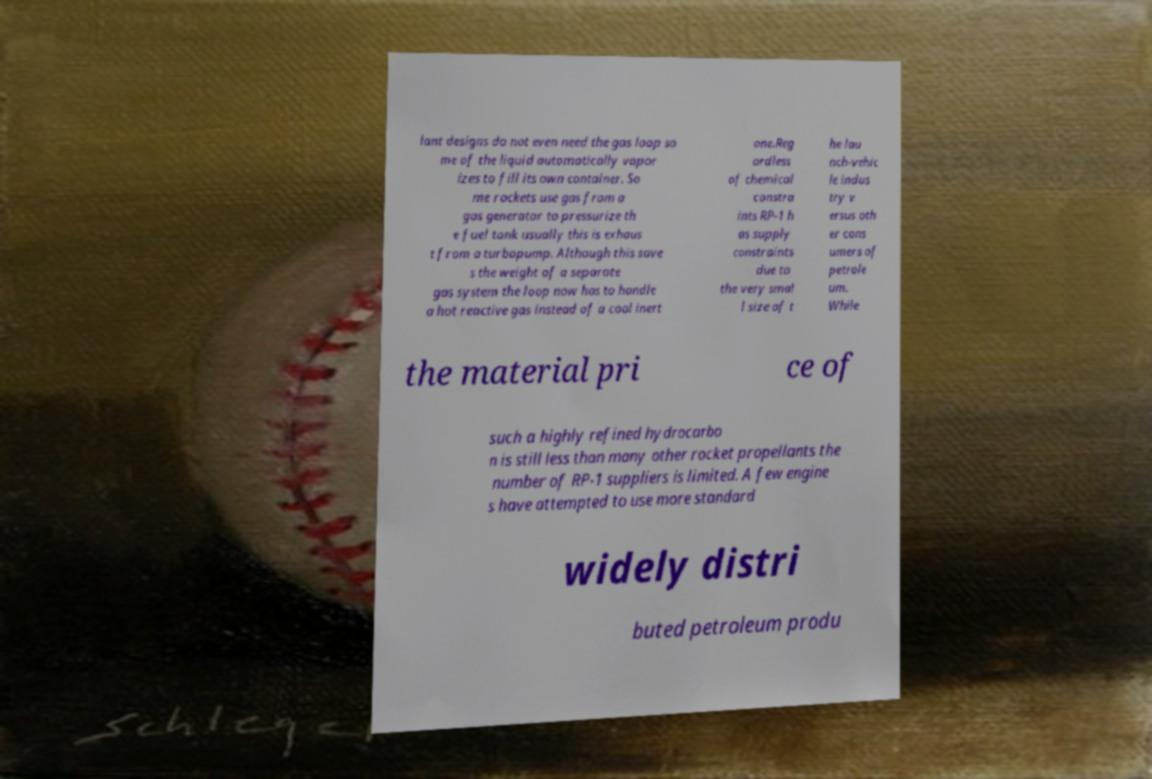There's text embedded in this image that I need extracted. Can you transcribe it verbatim? lant designs do not even need the gas loop so me of the liquid automatically vapor izes to fill its own container. So me rockets use gas from a gas generator to pressurize th e fuel tank usually this is exhaus t from a turbopump. Although this save s the weight of a separate gas system the loop now has to handle a hot reactive gas instead of a cool inert one.Reg ardless of chemical constra ints RP-1 h as supply constraints due to the very smal l size of t he lau nch-vehic le indus try v ersus oth er cons umers of petrole um. While the material pri ce of such a highly refined hydrocarbo n is still less than many other rocket propellants the number of RP-1 suppliers is limited. A few engine s have attempted to use more standard widely distri buted petroleum produ 